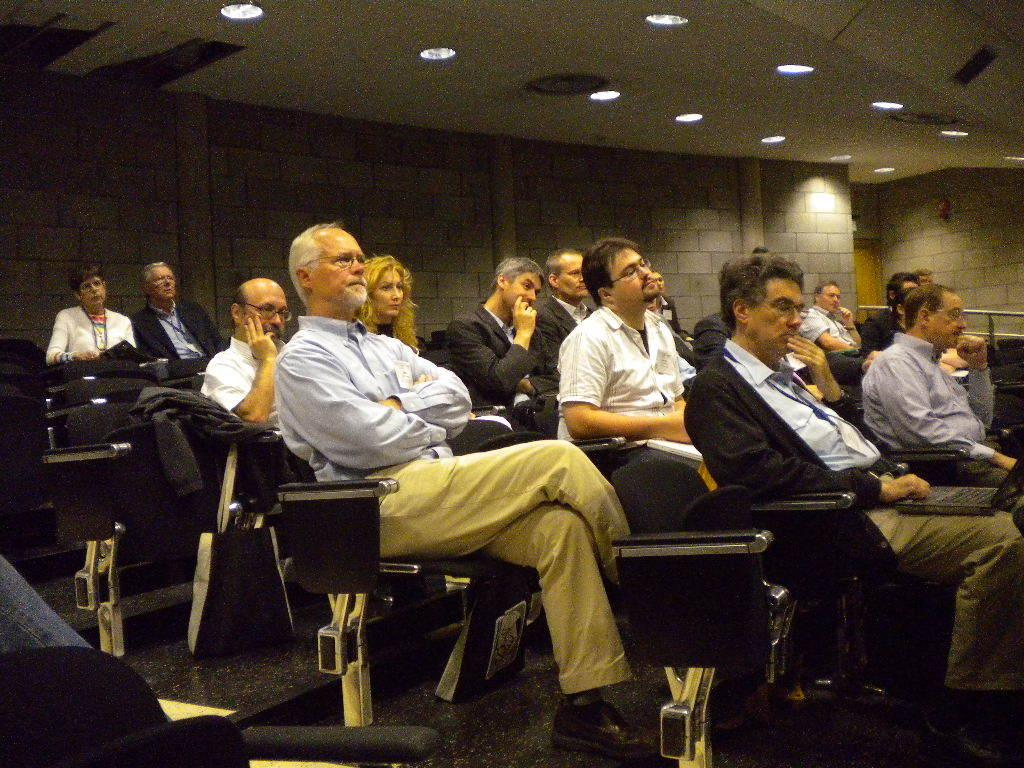What is the main subject of the image? The main subject of the image is a group of people. What are the people doing in the image? The people are sitting on chairs in the image. Can you describe what some of the people are holding? Some people are holding objects in their hands in the image. What can be seen attached to the roof in the image? There are lights attached to the roof in the image. What type of industry is depicted in the image? There is no industry depicted in the image; it features a group of people sitting on chairs. What is the chance of winning a prize in the image? There is no mention of a prize or any game of chance in the image. 